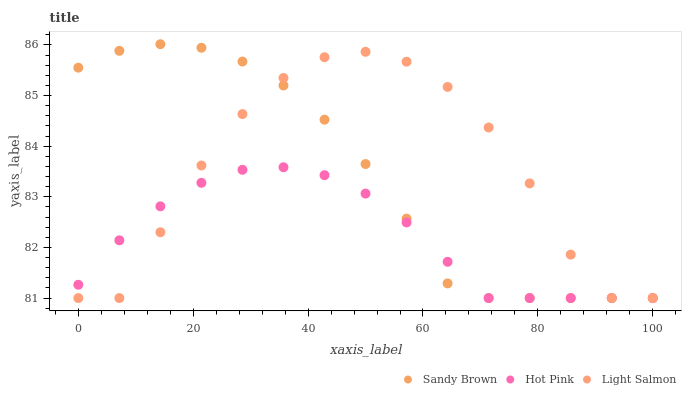Does Hot Pink have the minimum area under the curve?
Answer yes or no. Yes. Does Light Salmon have the maximum area under the curve?
Answer yes or no. Yes. Does Sandy Brown have the minimum area under the curve?
Answer yes or no. No. Does Sandy Brown have the maximum area under the curve?
Answer yes or no. No. Is Hot Pink the smoothest?
Answer yes or no. Yes. Is Light Salmon the roughest?
Answer yes or no. Yes. Is Sandy Brown the smoothest?
Answer yes or no. No. Is Sandy Brown the roughest?
Answer yes or no. No. Does Light Salmon have the lowest value?
Answer yes or no. Yes. Does Sandy Brown have the highest value?
Answer yes or no. Yes. Does Hot Pink have the highest value?
Answer yes or no. No. Does Sandy Brown intersect Light Salmon?
Answer yes or no. Yes. Is Sandy Brown less than Light Salmon?
Answer yes or no. No. Is Sandy Brown greater than Light Salmon?
Answer yes or no. No. 